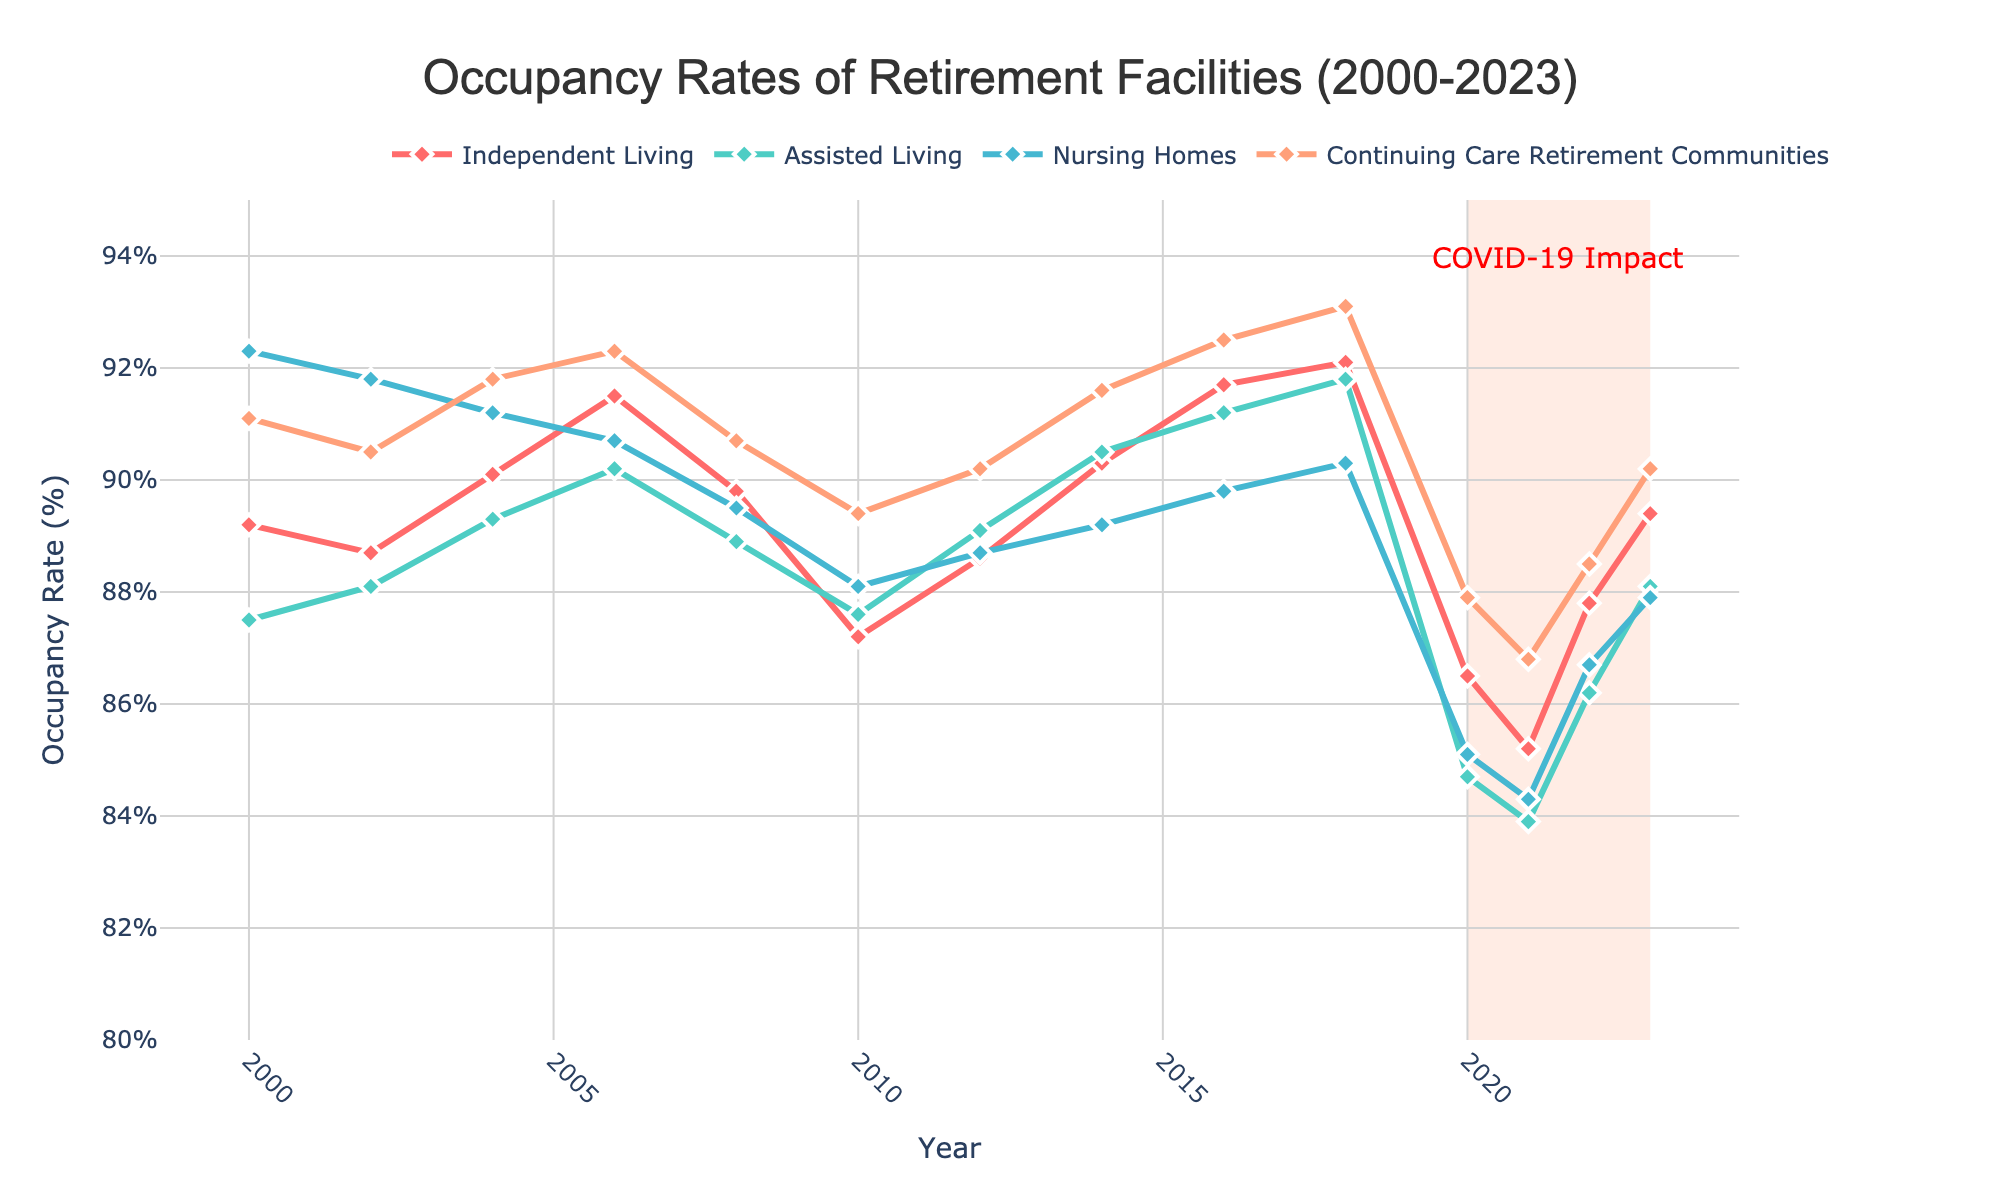What year had the highest occupancy rate for Independent Living? Scan the line for Independent Living and identify the peak value. The tallest point in the red line occurs in 2018 with a rate of 92.1%.
Answer: 2018 How did the occupancy rate for Nursing Homes change from 2000 to 2023? Look at the start and end points of the Nursing Homes line (blue line). The rate decreased from 92.3% in 2000 to 87.9% in 2023.
Answer: Decreased Which facility type had the lowest occupancy rate in 2021? Compare the values for all facilities in 2021. The Assisted Living rate (green line) is the lowest at 83.9%.
Answer: Assisted Living What's the average occupancy rate for Continuing Care Retirement Communities from 2020 to 2023? Find the sum of the values for 2020, 2021, 2022, and 2023 for Continuing Care Retirement Communities (orange line) and divide by 4. (87.9 + 86.8 + 88.5 + 90.2) / 4 = 88.35%
Answer: 88.35% How does the occupancy rate for Assisted Living in 2020 compare to 2016? Identify the values for Assisted Living in 2020 and 2016. 2020 has a rate of 84.7% and 2016 has a rate of 91.2%, so 2020 is lower.
Answer: Lower What's the difference in occupancy rates between Independent Living and Nursing Homes in 2004? Find the difference between the rates of Independent Living (90.1%) and Nursing Homes (91.2%) in 2004. 91.2 - 90.1 = 1.1%
Answer: 1.1% What trend do you notice in occupancy rates during the shaded COVID-19 period from 2020 to 2023? Identify the changes in the lines during the period 2020-2023. All facility types show a decline around 2020, followed by a slight recovery towards 2023.
Answer: Decline followed by recovery Which year shows a significant drop for all facility types? Identify the year where all lines show a noticeable decrease. The year 2020 shows a significant drop across all facility types.
Answer: 2020 How did the occupancy rate for Continuing Care Retirement Communities change right after the COVID-19 period? Compare the rate at the end of the COVID-19 period (2023) to the beginning (2020). The rate in 2020 is 87.9%, and it increased to 90.2% by 2023.
Answer: Increased 